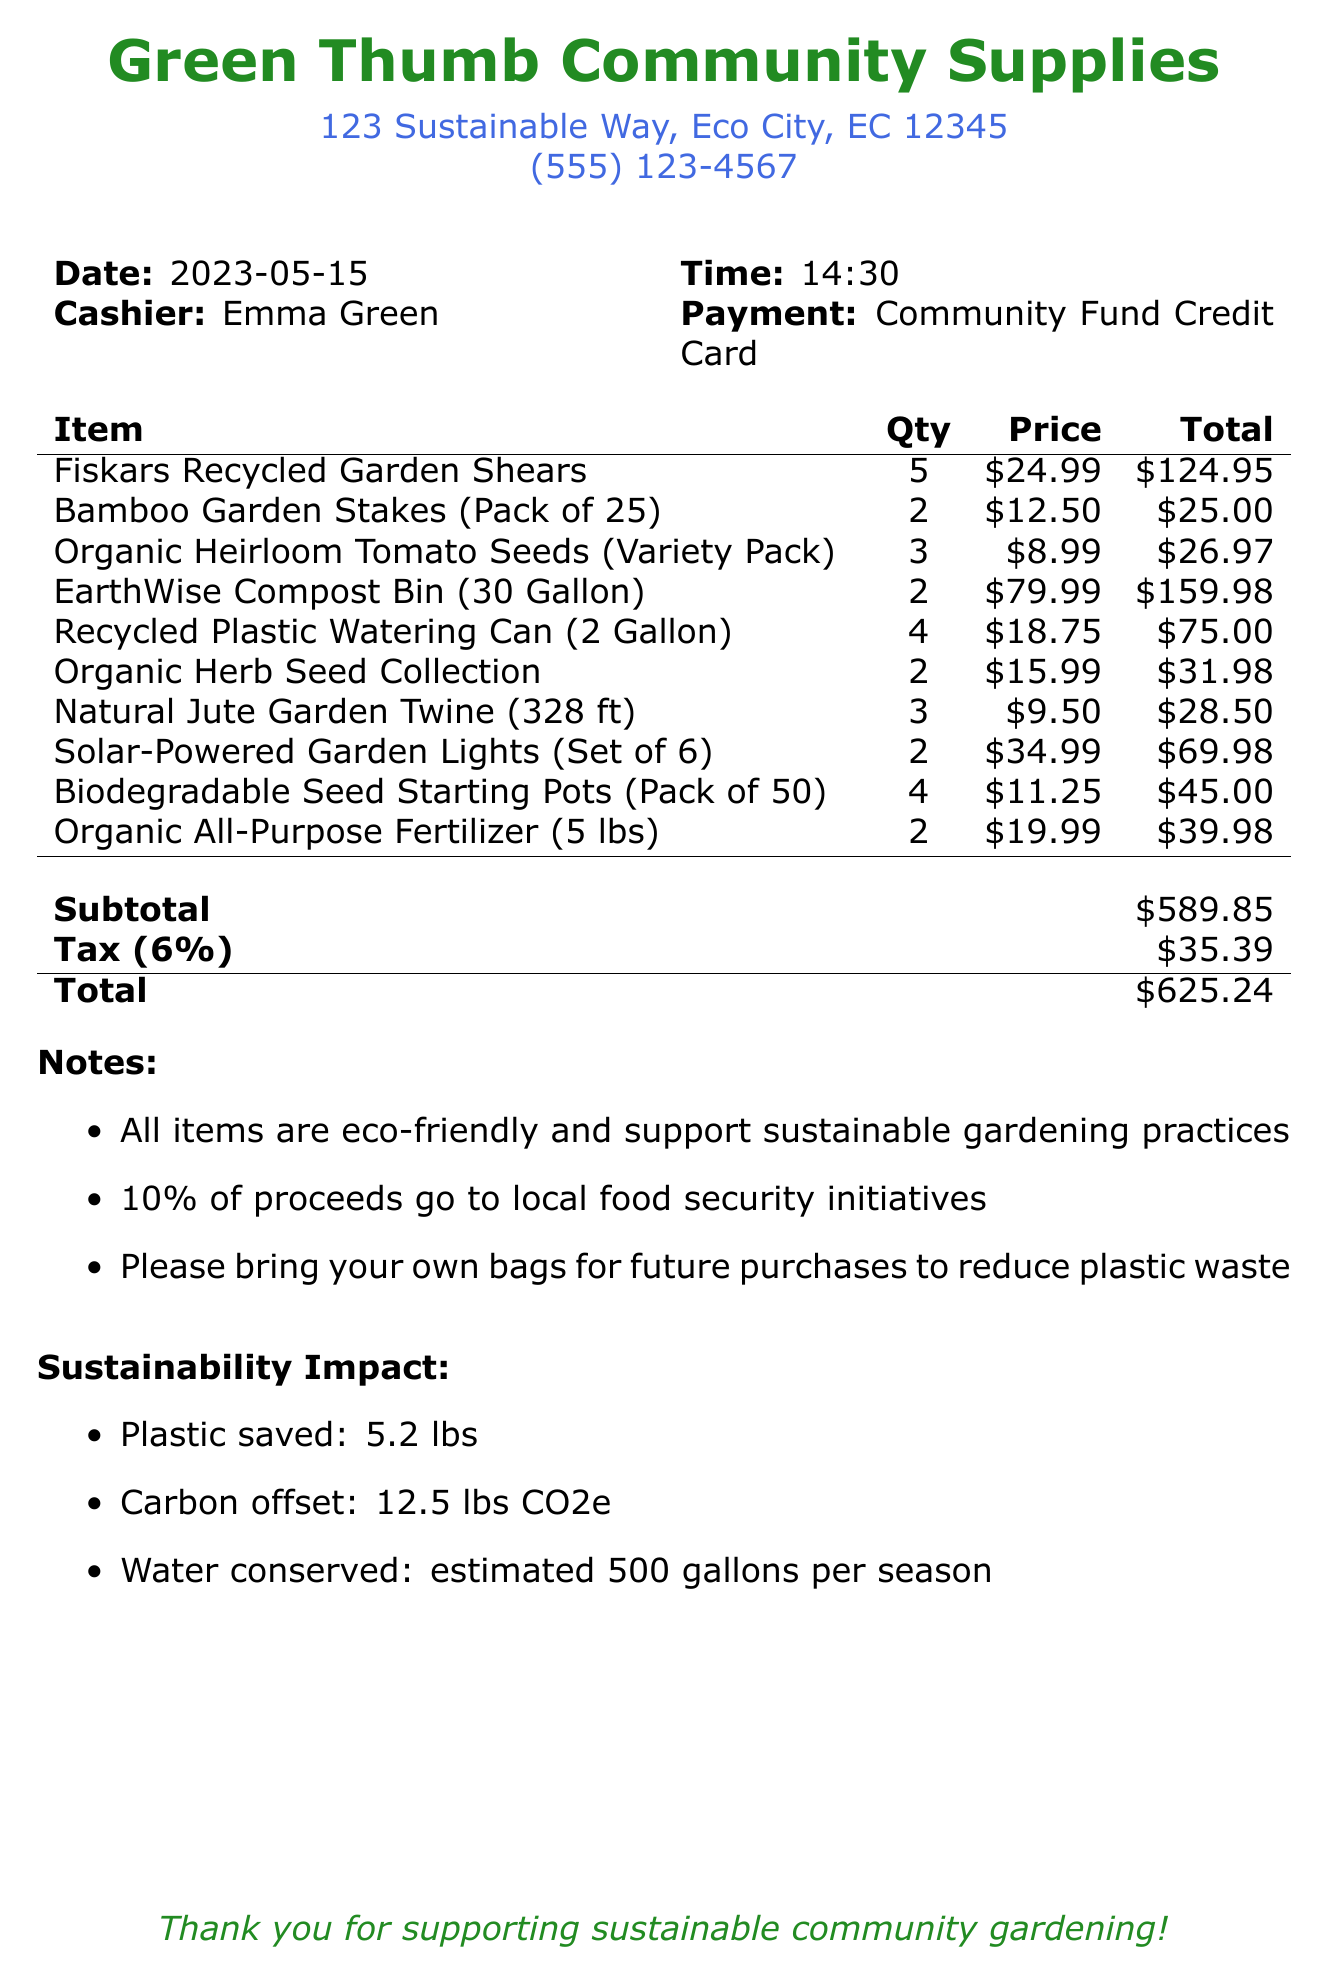What is the name of the store? The store name is located at the top of the document.
Answer: Green Thumb Community Supplies What was the date of the purchase? The purchase date is mentioned just below the store information.
Answer: 2023-05-15 How many organic heirloom tomato seed packets were purchased? The quantity of organic heirloom tomato seed packets is listed in the items section.
Answer: 3 What is the total amount spent on this receipt? The total amount spent is found in the summary at the end of the document.
Answer: $625.24 What percentage of proceeds goes to local food security initiatives? The percentage is stated in the notes section of the receipt.
Answer: 10% How many Eco-friendly items were purchased in the transaction? This requires adding the quantities of eco-friendly items listed.
Answer: 22 What is the tax rate applied to the purchase? The tax rate is given in the summary section of the receipt.
Answer: 6% What sustainability impact is listed for water conservation? The water conservation impact is mentioned in the sustainability impact section.
Answer: estimated 500 gallons per season What form of payment was used for this transaction? The payment method is mentioned alongside the cashier information.
Answer: Community Fund Credit Card 